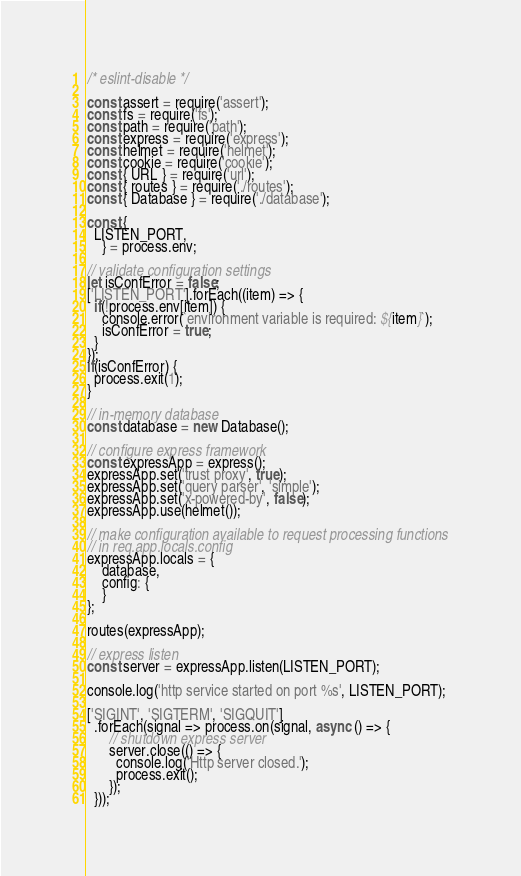Convert code to text. <code><loc_0><loc_0><loc_500><loc_500><_JavaScript_>/* eslint-disable */

const assert = require('assert');
const fs = require('fs');
const path = require('path');
const express = require('express');
const helmet = require('helmet');
const cookie = require('cookie');
const { URL } = require('url');
const { routes } = require('./routes');
const { Database } = require('./database');

const {
  LISTEN_PORT,
    } = process.env;

// validate configuration settings
let isConfError = false;
['LISTEN_PORT'].forEach((item) => {
  if(!process.env[item]) {
    console.error(`environment variable is required: ${item}`);
    isConfError = true;
  }
});
if(isConfError) {
  process.exit(1);
}

// in-memory database
const database = new Database();

// configure express framework
const expressApp = express();
expressApp.set('trust proxy', true);
expressApp.set('query parser', 'simple');
expressApp.set('x-powered-by', false);
expressApp.use(helmet());

// make configuration available to request processing functions
// in req.app.locals.config
expressApp.locals = {
    database,
    config: {
    }
};

routes(expressApp);

// express listen
const server = expressApp.listen(LISTEN_PORT);

console.log('http service started on port %s', LISTEN_PORT);

['SIGINT', 'SIGTERM', 'SIGQUIT']
  .forEach(signal => process.on(signal, async () => {
      // shutdown express server
      server.close(() => {
        console.log('Http server closed.');
        process.exit();
      });
  }));

</code> 